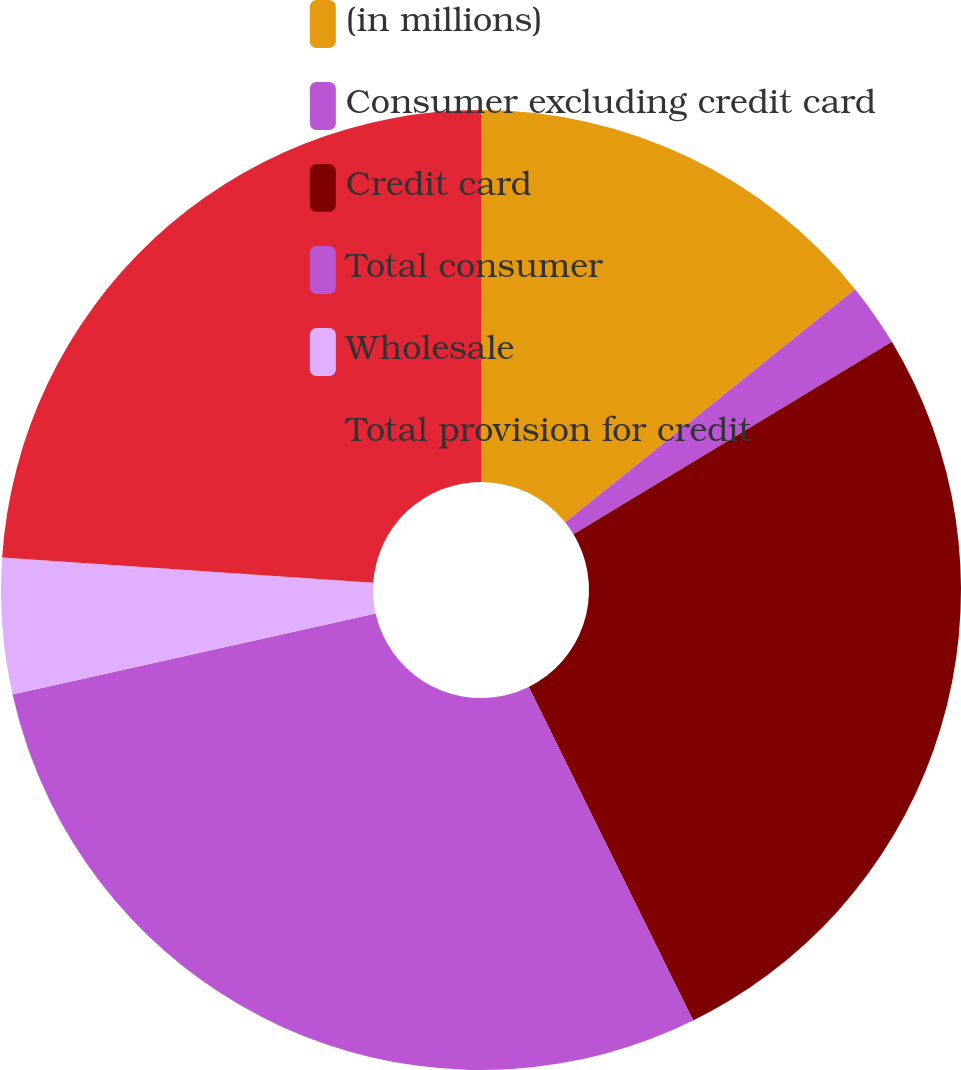Convert chart to OTSL. <chart><loc_0><loc_0><loc_500><loc_500><pie_chart><fcel>(in millions)<fcel>Consumer excluding credit card<fcel>Credit card<fcel>Total consumer<fcel>Wholesale<fcel>Total provision for credit<nl><fcel>14.22%<fcel>2.13%<fcel>26.36%<fcel>28.79%<fcel>4.57%<fcel>23.92%<nl></chart> 